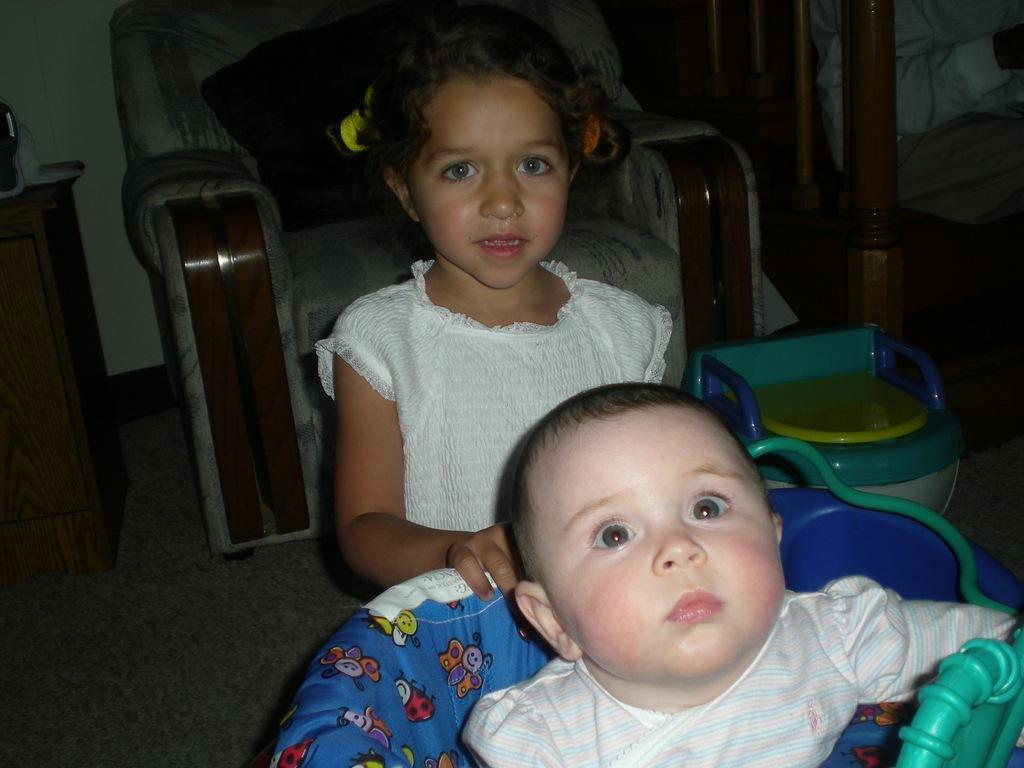Could you give a brief overview of what you see in this image? This picture is clicked inside. In the foreground there is a kid wearing white color dress and sitting on the chair and we can see a girl wearing white color t-shirt and standing on the ground. In the background we can see the couch and many other objects placed on the ground. On the left there is a wooden cabinet. On the right there is a pillar. 